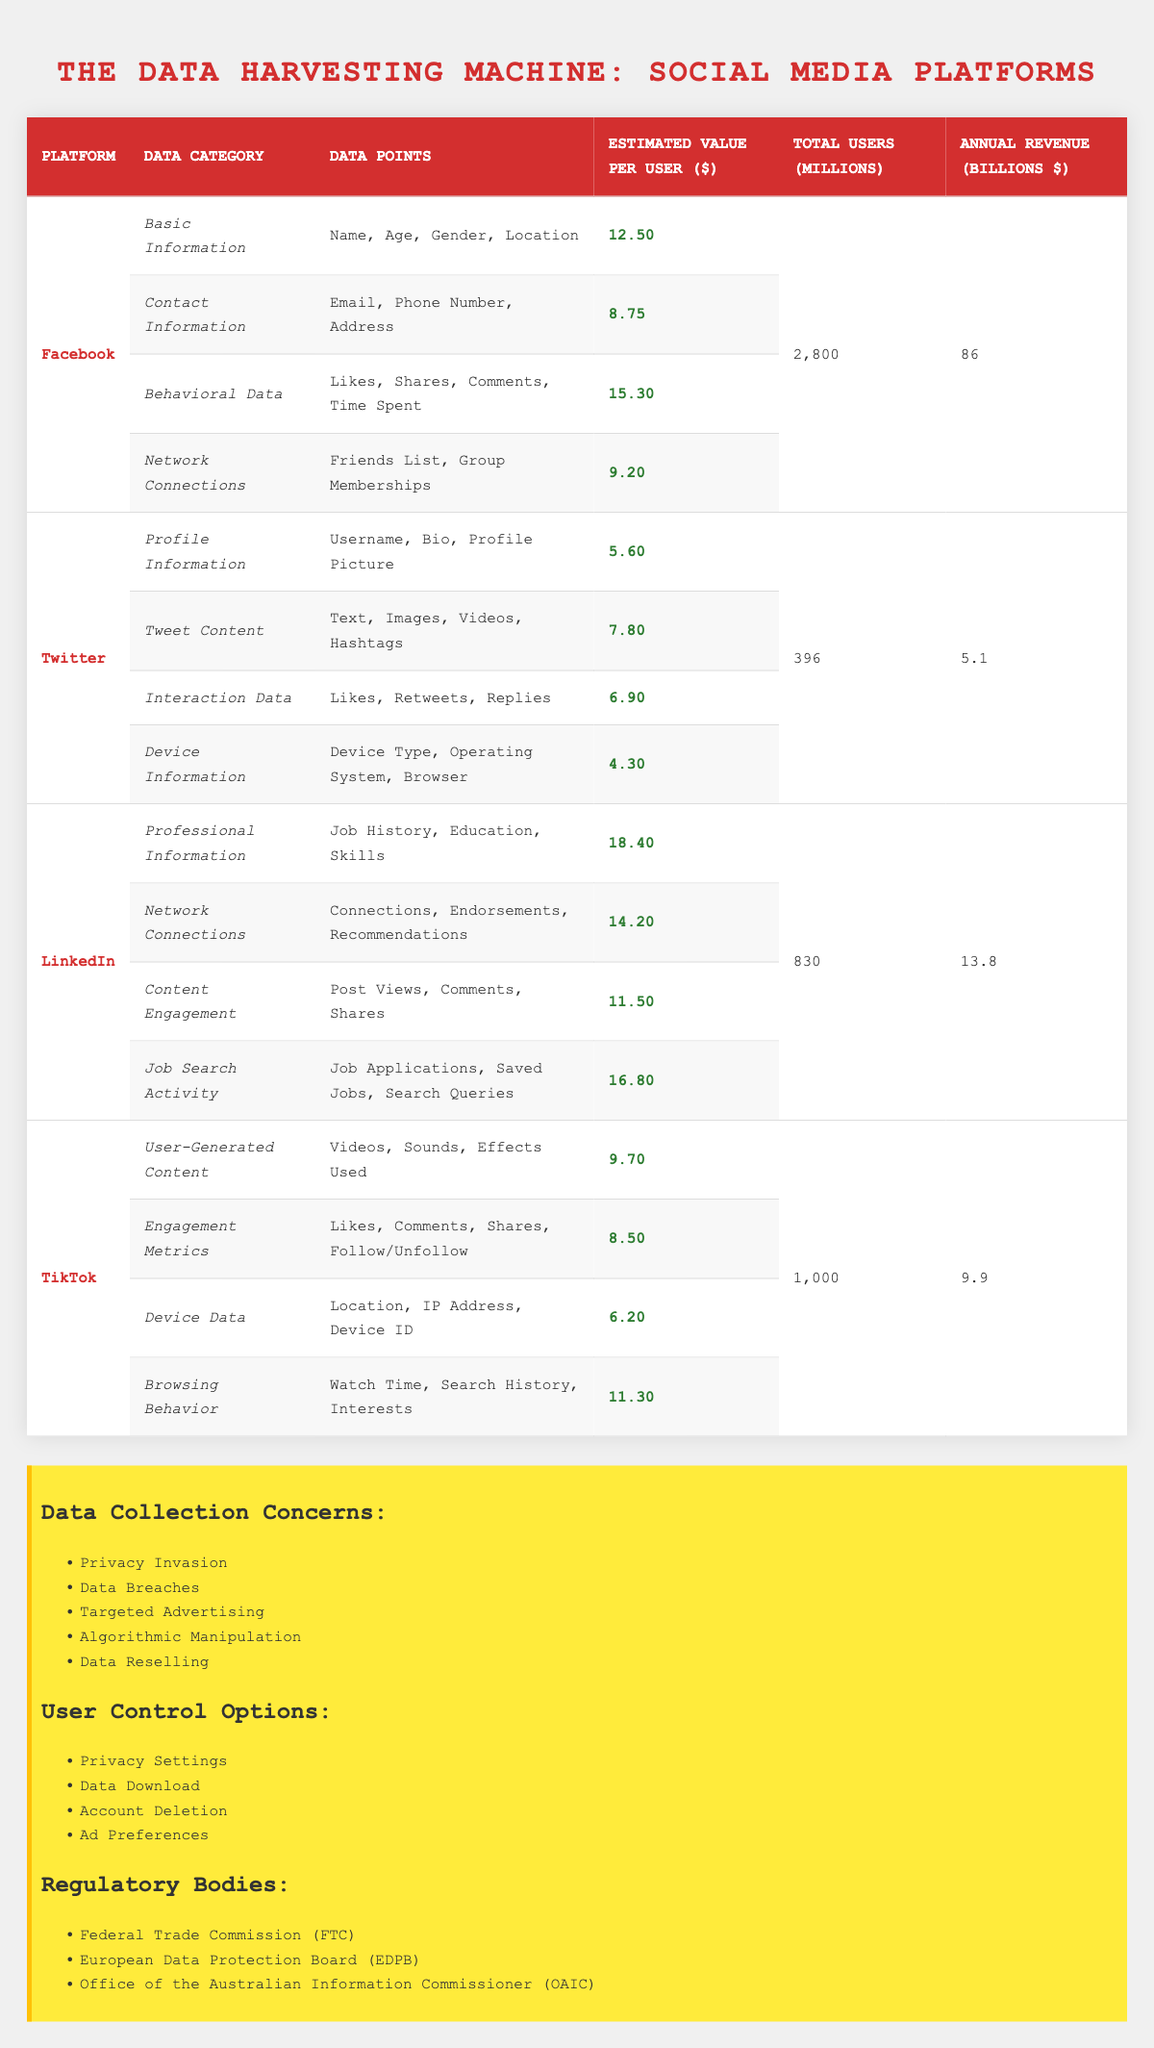What social media platform has the highest estimated value per user for behavioral data? Looking at the behavioral data for each platform, Facebook has an estimated value per user of 15.30, while Twitter has 6.90, LinkedIn has no specific behavioral data category, and TikTok has no specific behavioral data category. Therefore, Facebook has the highest value for behavioral data.
Answer: Facebook What is the total estimated value per user across all categories for LinkedIn? For LinkedIn, the estimated values per user for each category are: Professional Information (18.40), Network Connections (14.20), Content Engagement (11.50), and Job Search Activity (16.80). Adding these values gives: 18.40 + 14.20 + 11.50 + 16.80 = 60.90.
Answer: 60.90 Is the total number of users for Facebook greater than the sum of users for Twitter and TikTok? The total number of users for Facebook is 2800 million, while the sum of users for Twitter (396 million) and TikTok (1000 million) is 1396 million. Since 2800 million is greater than 1396 million, the statement is true.
Answer: Yes Which platform has the smallest annual revenue? The table shows that the annual revenues are: Facebook (86 billion), Twitter (5.1 billion), LinkedIn (13.8 billion), and TikTok (9.9 billion). Among these, Twitter has the smallest revenue of 5.1 billion.
Answer: Twitter What is the average estimated value per user across all data categories for TikTok? TikTok's estimated values per user are: User-Generated Content (9.70), Engagement Metrics (8.50), Device Data (6.20), and Browsing Behavior (11.30). Summing these gives: 9.70 + 8.50 + 6.20 + 11.30 = 35.70. To find the average, divide by 4: 35.70 / 4 = 8.93.
Answer: 8.93 Does N/A exist in the data points listed for the data categories? Each category lists specific data points without any indications of N/A. Therefore, the answer is that there are no instances of N/A reported in the data points across categories.
Answer: No How much more data value per user does LinkedIn have in the Job Search Activity category compared to Twitter's Interaction Data category? LinkedIn has 16.80 estimated value per user for Job Search Activity, while Twitter has 6.90 for Interaction Data. The difference is 16.80 - 6.90 = 9.90.
Answer: 9.90 Which platform collects data on 'Browsing Behavior'? Upon reviewing each platform's collected data categories, TikTok specifically lists 'Browsing Behavior' as one of its data categories.
Answer: TikTok 